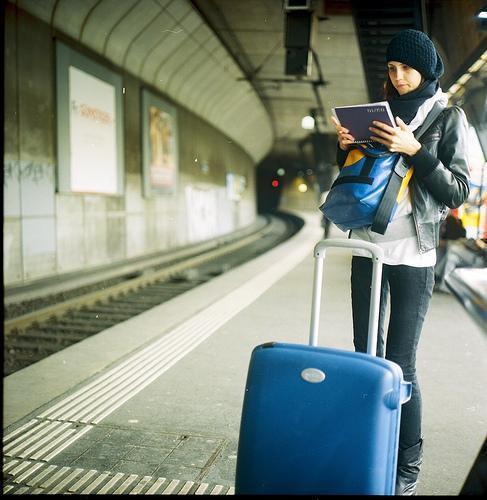How many people are shown?
Give a very brief answer. 1. How many bags are shown?
Give a very brief answer. 2. 